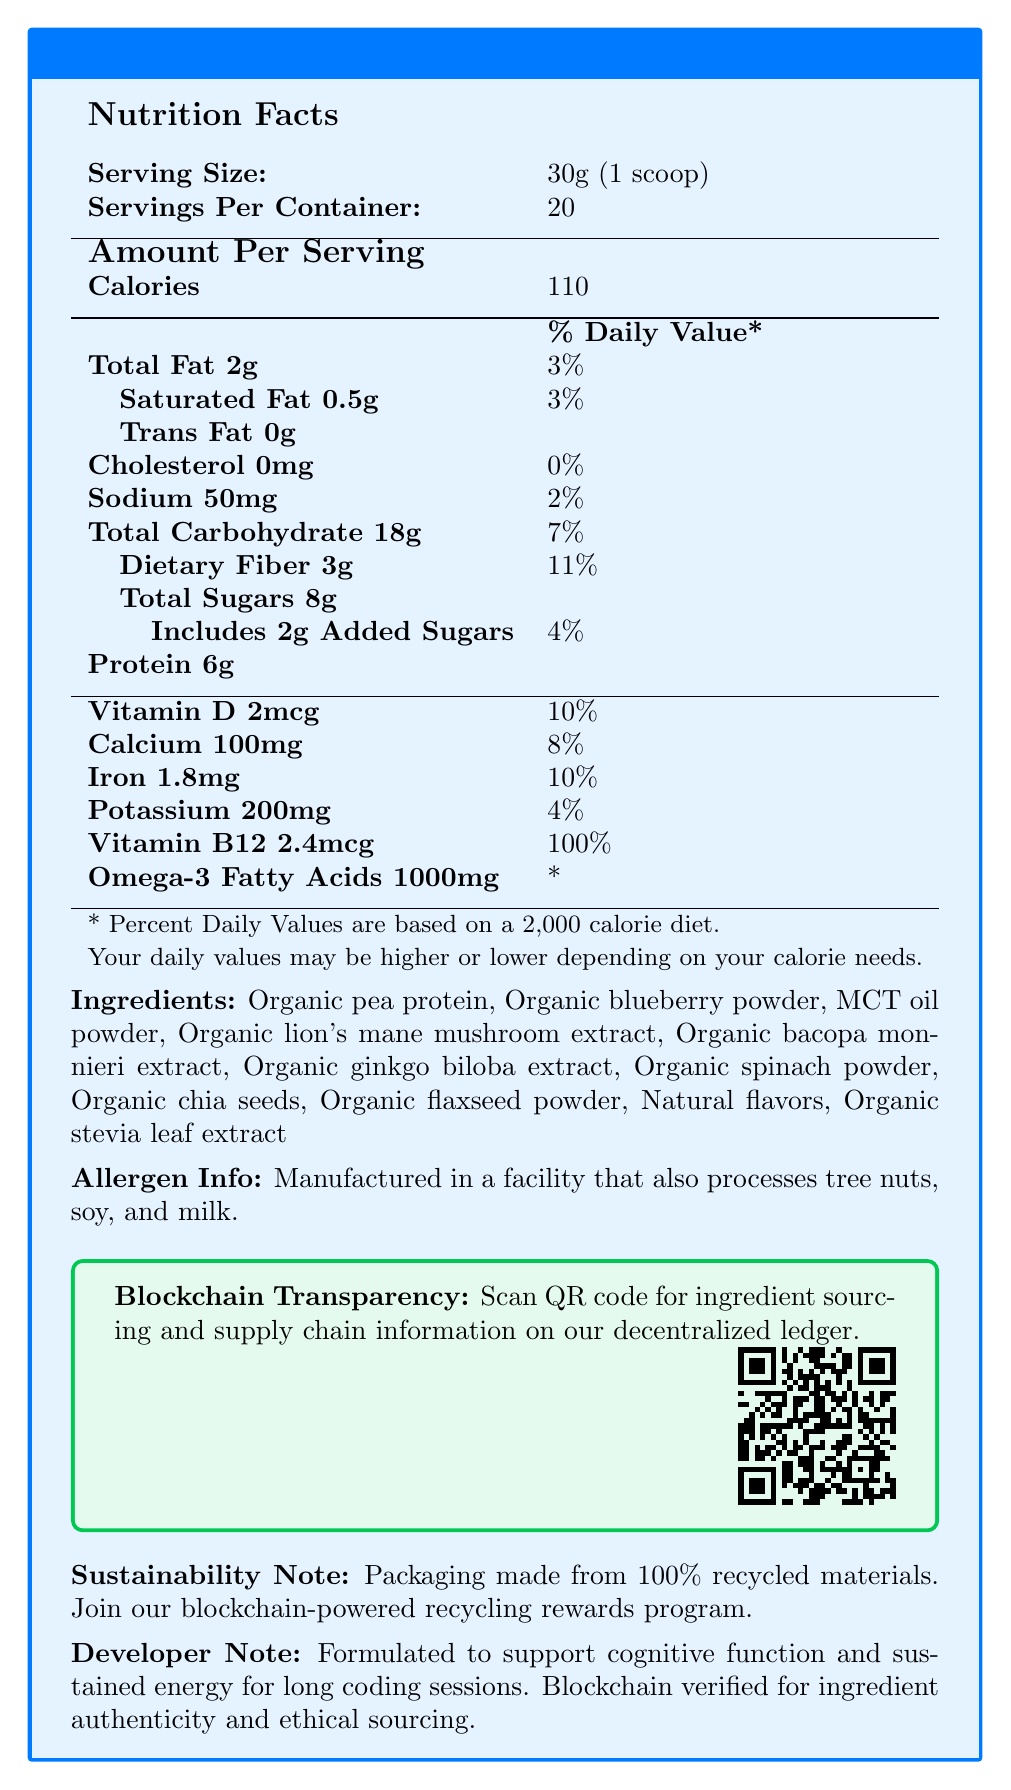what is the serving size? The serving size is stated at the top of the Nutrition Facts section.
Answer: 30g (1 scoop) how many servings are there per container? The number of servings per container is also listed at the top of the Nutrition Facts section.
Answer: 20 how many calories are in one serving? The calories per serving are listed under the Amount Per Serving section.
Answer: 110 how much total fat is there per serving, and what is the % daily value? The total fat content and its % daily value are listed together in the Nutrition Facts section.
Answer: 2g, 3% list three ingredients in the smoothie mix These are listed under the Ingredients section.
Answer: Organic pea protein, Organic blueberry powder, MCT oil powder how much protein is in one serving? The protein content per serving is listed under the Amount Per Serving section.
Answer: 6g what is the % daily value for Vitamin D? The % daily value for Vitamin D is given in the Amount Per Serving section.
Answer: 10% what facilities is this product manufactured in relation to allergens? The allergen information is stated under Allergen Info.
Answer: A facility that also processes tree nuts, soy, and milk. which of the following is true about Omega-3 Fatty Acids per serving? A. 100mg B. 500mg C. 1000mg D. 1500mg The Amount Per Serving section states that there are 1000mg of Omega-3 Fatty Acids per serving.
Answer: C what fruits or plants are used in the ingredients to enhance cognitive function? A. Organic lion's mane mushroom B. Organic blueberry powder C. Organic spinach powder D. All of the above All mentioned ingredients are part of the mix as listed in the Ingredients section.
Answer: D can the exact source of ingredients be tracked using blockchain? The document states that blockchain transparency can be confirmed by scanning a QR Code.
Answer: Yes is the product packaging sustainable? The Sustainability Note mentions that the packaging is made from 100% recycled materials.
Answer: Yes what daily value provides a substantial amount and is essential for long coding sessions? The daily value for Vitamin B12 is highest at 100%, as mentioned in the Amount Per Serving section.
Answer: Vitamin B12 at 100% how does the document suggest verifying the authenticity and ethical sourcing of ingredients? The Blockchain Transparency section advises scanning a QR code for ingredient sourcing and supply chain information.
Answer: By scanning a QR code describe the main idea of the document The document details the nutritional content, ingredients, and allergen information of the smoothie mix, along with additional notes on blockchain transparency for ingredient sourcing and sustainability.
Answer: The document provides nutritional information and highlights the cognitive benefits of the CodeBoost Brain Fuel Smoothie Mix. It also emphasizes blockchain transparency and sustainable practices. what type of diet are the % daily values based on? This information is footnoted at the bottom of the Nutrition Facts section.
Answer: A 2,000 calorie diet how many carbs are there per serving? includes total and as %? The total carbohydrate content per serving and its % daily value are mentioned in the Amount Per Serving section.
Answer: 18g, 7% what is the added sugar content per serving? The added sugar content per serving is listed under the Sugar category in the Amount Per Serving section.
Answer: 2g what type of blockchain information can be accessed through the QR code? what specific data? The document mentions blockchain transparency and scanning a QR code, but it does not specify the exact data accessible through the QR code.
Answer: Cannot be determined if you want to join a rewards program related to the product, what should you consider? The recycling program is mentioned under the Sustainability Note, implying participation incentives.
Answer: The blockchain-powered recycling rewards program suggests joining it as part of sustainability efforts. 